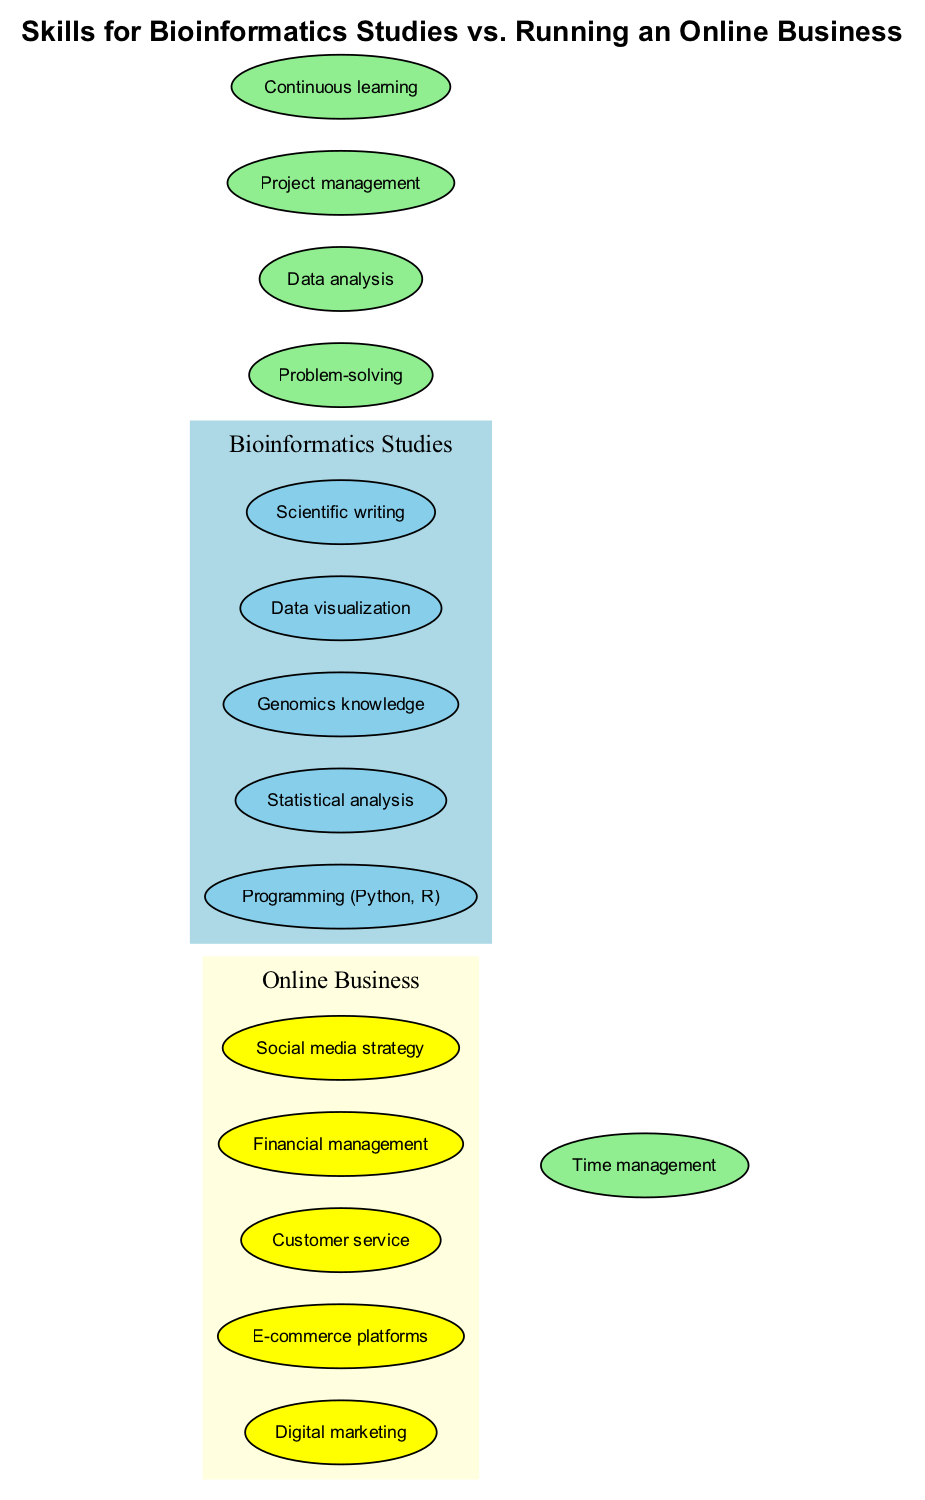What skills are unique to Bioinformatics Studies? The diagram shows skills listed under the "Bioinformatics Studies" set. These skills are identified as not overlapping with "Online Business." The skills listed are Programming (Python, R), Statistical analysis, Genomics knowledge, Data visualization, and Scientific writing.
Answer: Programming (Python, R), Statistical analysis, Genomics knowledge, Data visualization, Scientific writing How many overlapping skills are there? The overlapping skills are found in the section that connects the two sets. Upon counting the listed skills in that area, there are five overlapping skills: Time management, Problem-solving, Data analysis, Project management, and Continuous learning.
Answer: 5 Which skill is shared between the two fields? The diagram indicates the skills found in the overlapping section, representing abilities applicable to both Bioinformatics Studies and an Online Business. The presence of Time management demonstrates this shared skill.
Answer: Time management What is a unique skill for Online Business? By examining the "Online Business" set, we can identify skills that are specific to that area and not found in "Bioinformatics Studies." Digital marketing is an example of a skill unique to Online Business.
Answer: Digital marketing What do the overlapping skills indicate about the two fields? The overlapping skills show that there are essential competencies that are valuable in both Bioinformatics Studies and running an Online Business, highlighting common requirements such as Time management, Problem-solving, and Data analysis. This suggests a convergence in skill application across disciplines.
Answer: Valuable competencies How many total skills are listed for Bioinformatics Studies? The total number of skills can be found by counting the elements in the "Bioinformatics Studies" set. There are five specific skills listed in that section.
Answer: 5 What is the relationship between Digital marketing and Time management in the diagram? A relationship exists as both skills are part of the overall skill set of their respective fields, but they are separated by the lack of overlap, indicating that Time management is essential in both areas while Digital marketing is exclusive to Online Business.
Answer: No direct relationship Which field has more skills listed? By comparing the number of unique skills in the "Bioinformatics Studies" set (5) and the "Online Business" set (5), it reveals that both fields have an equal number of unique skills, totaling five each.
Answer: Equal number (5 each) 